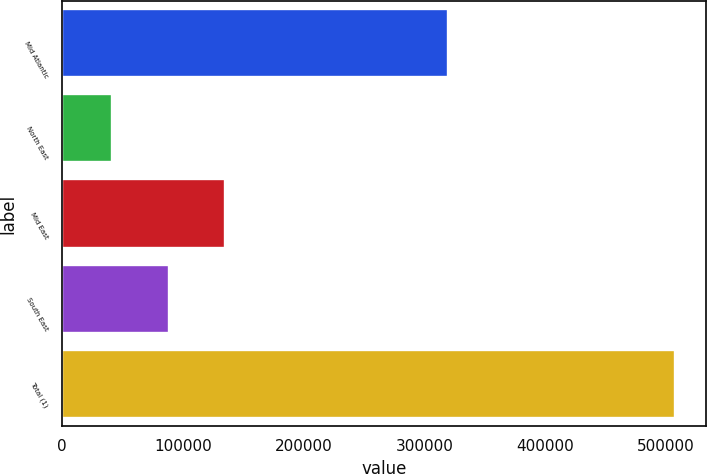Convert chart to OTSL. <chart><loc_0><loc_0><loc_500><loc_500><bar_chart><fcel>Mid Atlantic<fcel>North East<fcel>Mid East<fcel>South East<fcel>Total (1)<nl><fcel>319958<fcel>41447<fcel>134723<fcel>88084.8<fcel>507825<nl></chart> 